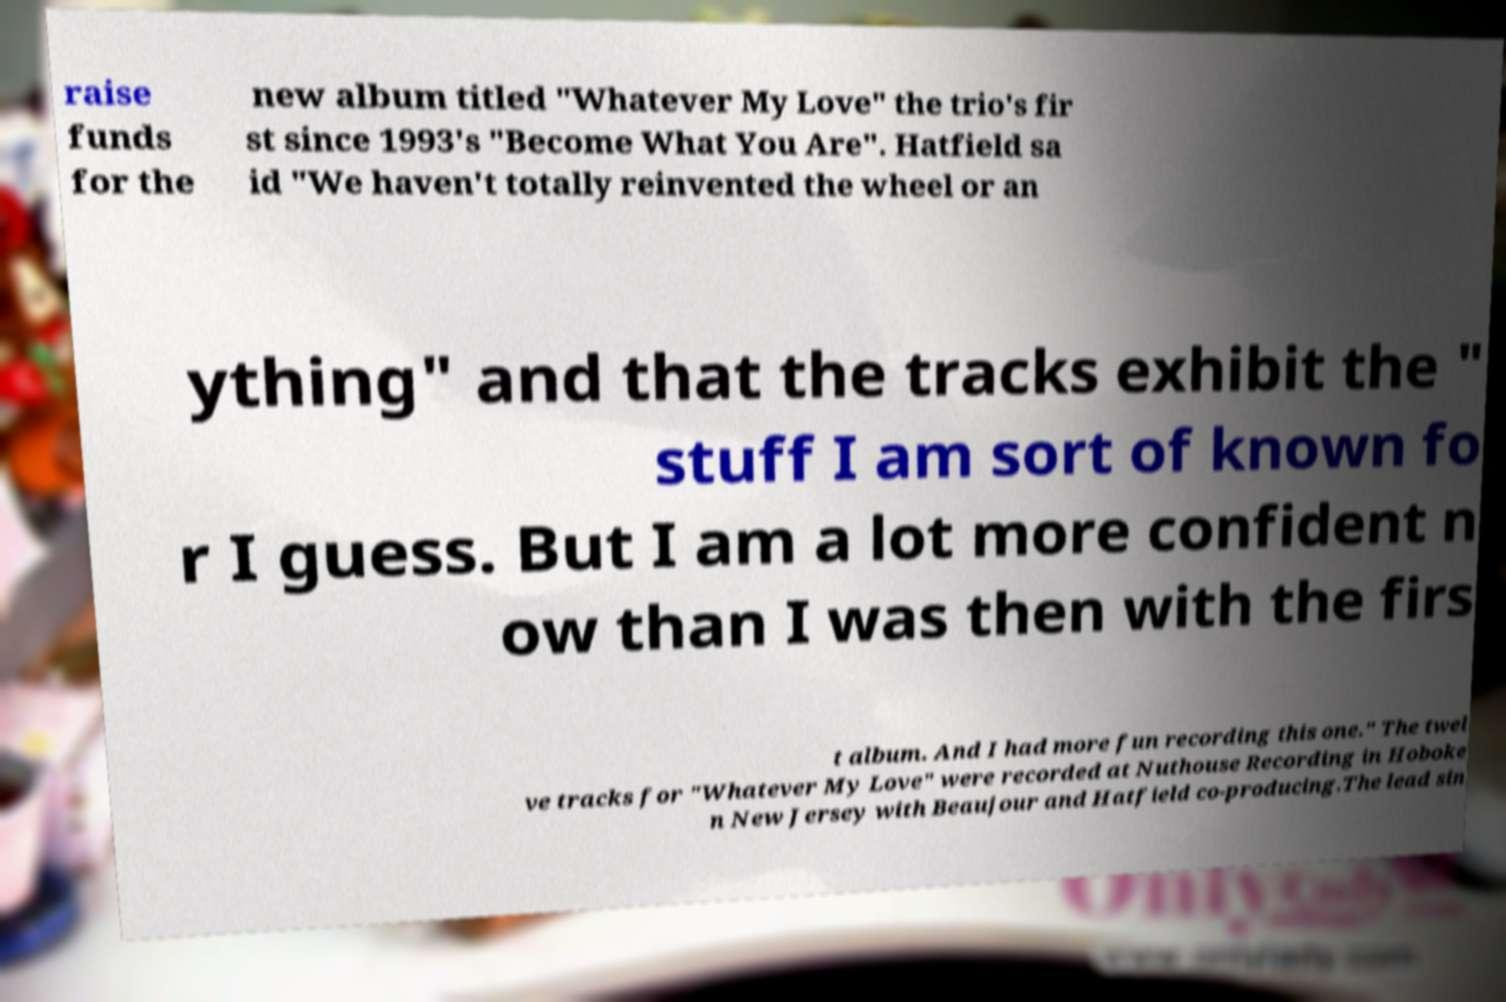Can you accurately transcribe the text from the provided image for me? raise funds for the new album titled "Whatever My Love" the trio's fir st since 1993's "Become What You Are". Hatfield sa id "We haven't totally reinvented the wheel or an ything" and that the tracks exhibit the " stuff I am sort of known fo r I guess. But I am a lot more confident n ow than I was then with the firs t album. And I had more fun recording this one." The twel ve tracks for "Whatever My Love" were recorded at Nuthouse Recording in Hoboke n New Jersey with Beaujour and Hatfield co-producing.The lead sin 